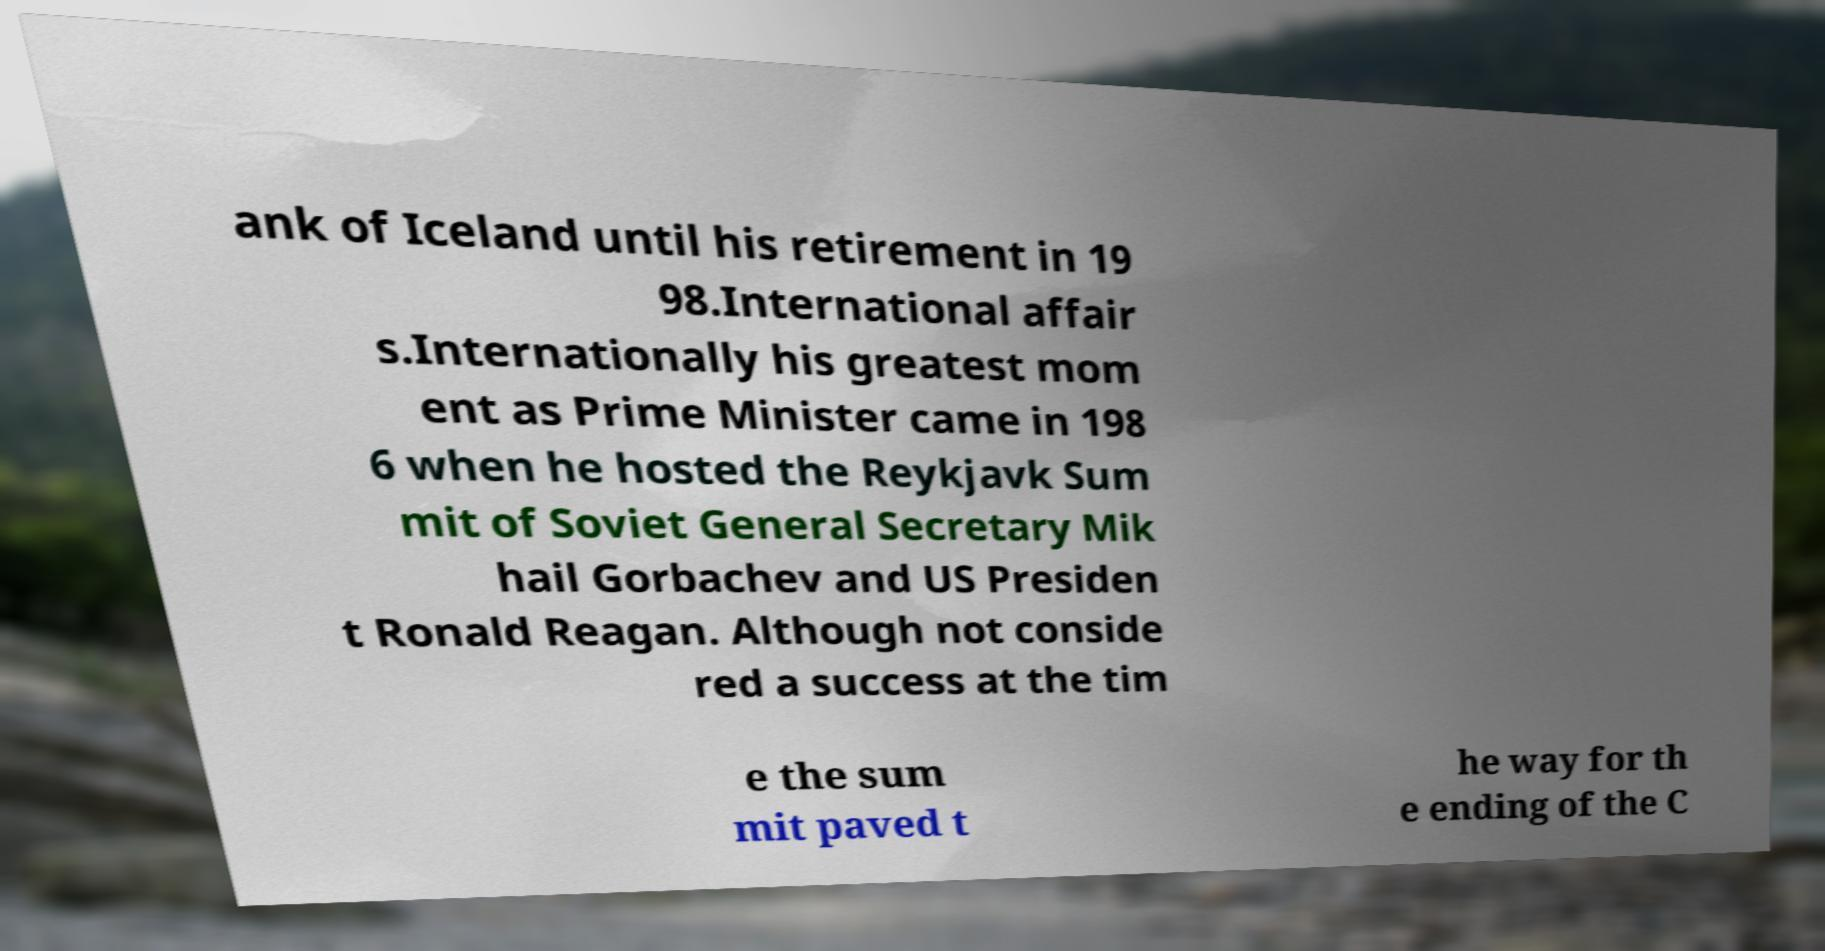Could you assist in decoding the text presented in this image and type it out clearly? ank of Iceland until his retirement in 19 98.International affair s.Internationally his greatest mom ent as Prime Minister came in 198 6 when he hosted the Reykjavk Sum mit of Soviet General Secretary Mik hail Gorbachev and US Presiden t Ronald Reagan. Although not conside red a success at the tim e the sum mit paved t he way for th e ending of the C 